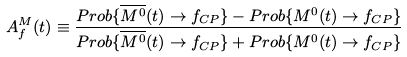Convert formula to latex. <formula><loc_0><loc_0><loc_500><loc_500>A ^ { M } _ { f } ( t ) \equiv \frac { P r o b \{ \overline { M ^ { 0 } } ( t ) \to f _ { C P } \} - P r o b \{ M ^ { 0 } ( t ) \to f _ { C P } \} } { P r o b \{ \overline { M ^ { 0 } } ( t ) \to f _ { C P } \} + P r o b \{ M ^ { 0 } ( t ) \to f _ { C P } \} }</formula> 